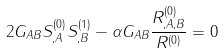Convert formula to latex. <formula><loc_0><loc_0><loc_500><loc_500>2 G _ { A B } S _ { , A } ^ { ( 0 ) } S _ { , B } ^ { ( 1 ) } - \alpha G _ { A B } \frac { R ^ { ( 0 ) } _ { , A , B } } { R ^ { ( 0 ) } } = 0</formula> 